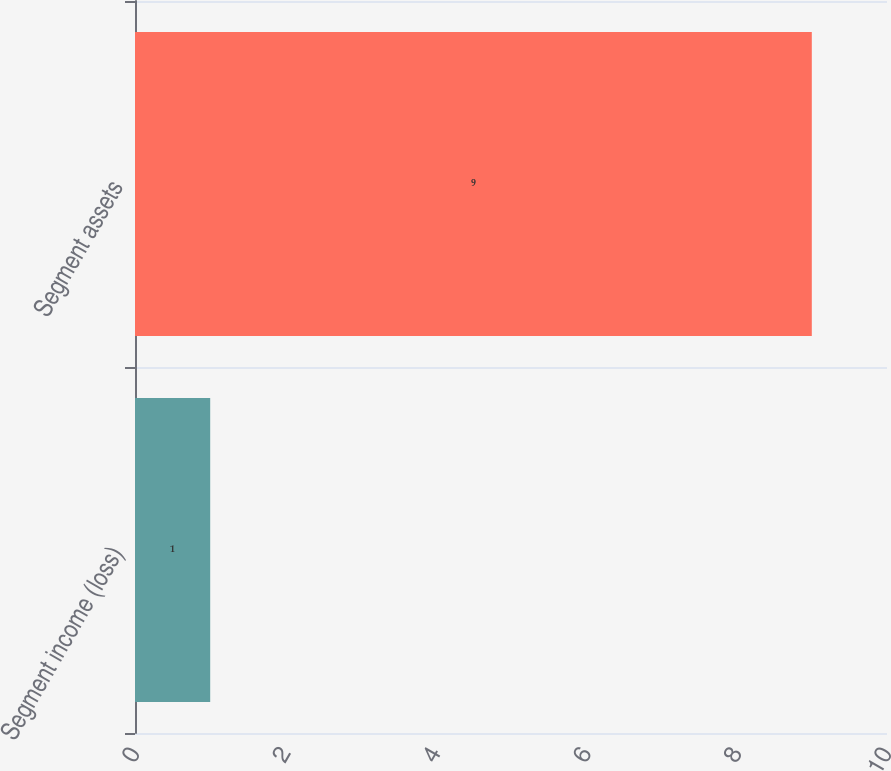<chart> <loc_0><loc_0><loc_500><loc_500><bar_chart><fcel>Segment income (loss)<fcel>Segment assets<nl><fcel>1<fcel>9<nl></chart> 